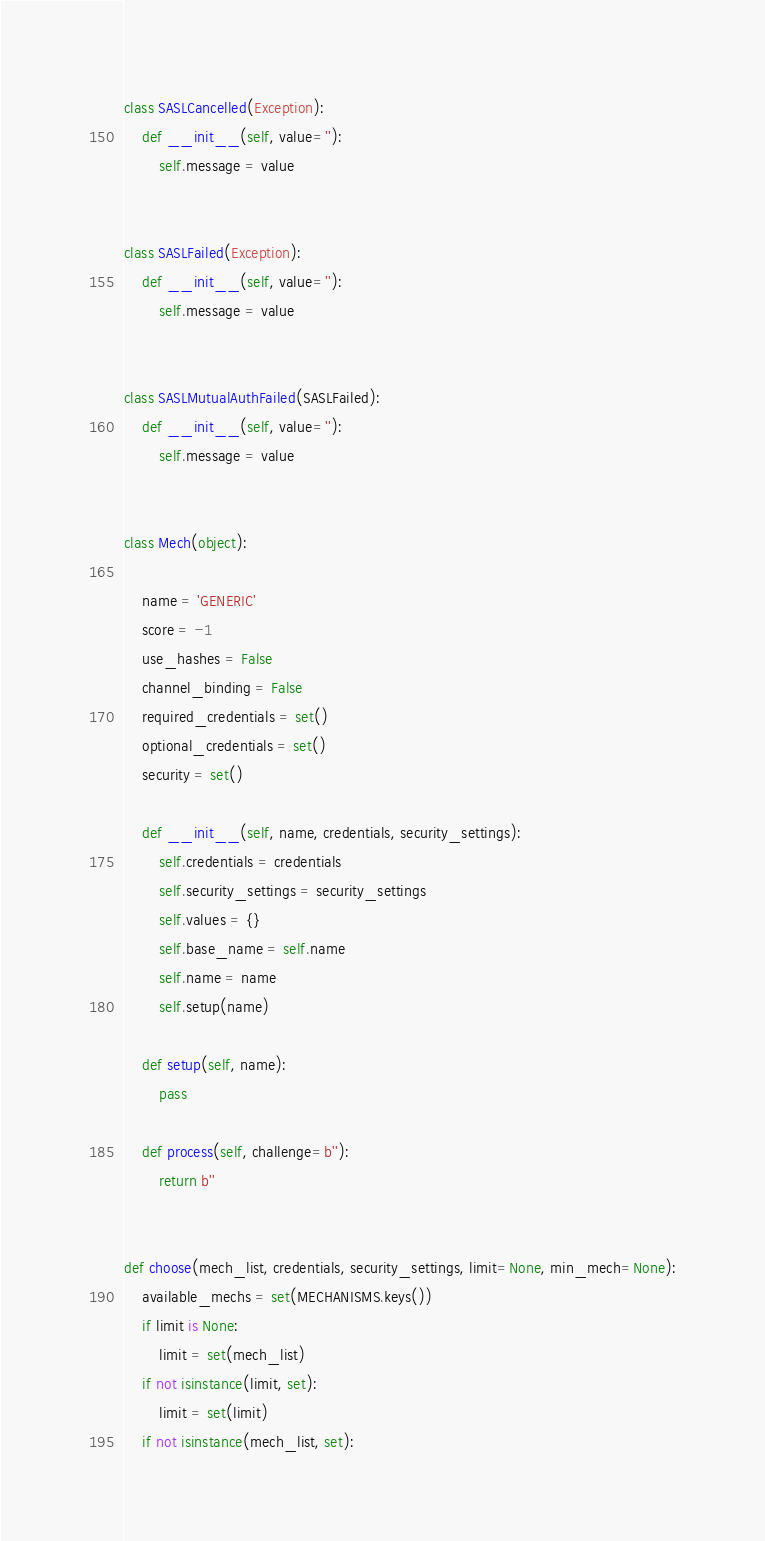Convert code to text. <code><loc_0><loc_0><loc_500><loc_500><_Python_>
class SASLCancelled(Exception):
    def __init__(self, value=''):
        self.message = value


class SASLFailed(Exception):
    def __init__(self, value=''):
        self.message = value


class SASLMutualAuthFailed(SASLFailed):
    def __init__(self, value=''):
        self.message = value


class Mech(object):

    name = 'GENERIC'
    score = -1
    use_hashes = False
    channel_binding = False
    required_credentials = set()
    optional_credentials = set()
    security = set()

    def __init__(self, name, credentials, security_settings):
        self.credentials = credentials
        self.security_settings = security_settings
        self.values = {}
        self.base_name = self.name
        self.name = name
        self.setup(name)

    def setup(self, name):
        pass

    def process(self, challenge=b''):
        return b''


def choose(mech_list, credentials, security_settings, limit=None, min_mech=None):
    available_mechs = set(MECHANISMS.keys())
    if limit is None:
        limit = set(mech_list)
    if not isinstance(limit, set):
        limit = set(limit)
    if not isinstance(mech_list, set):</code> 